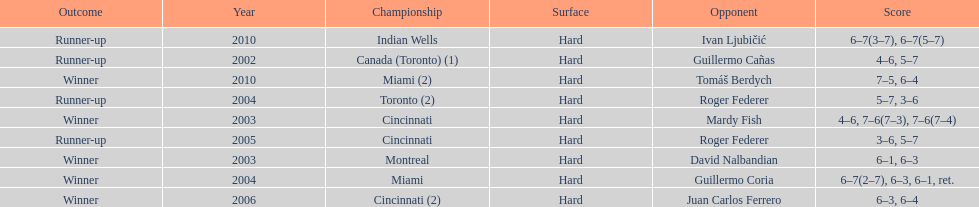How many times were roddick's opponents not from the usa? 8. Can you parse all the data within this table? {'header': ['Outcome', 'Year', 'Championship', 'Surface', 'Opponent', 'Score'], 'rows': [['Runner-up', '2010', 'Indian Wells', 'Hard', 'Ivan Ljubičić', '6–7(3–7), 6–7(5–7)'], ['Runner-up', '2002', 'Canada (Toronto) (1)', 'Hard', 'Guillermo Cañas', '4–6, 5–7'], ['Winner', '2010', 'Miami (2)', 'Hard', 'Tomáš Berdych', '7–5, 6–4'], ['Runner-up', '2004', 'Toronto (2)', 'Hard', 'Roger Federer', '5–7, 3–6'], ['Winner', '2003', 'Cincinnati', 'Hard', 'Mardy Fish', '4–6, 7–6(7–3), 7–6(7–4)'], ['Runner-up', '2005', 'Cincinnati', 'Hard', 'Roger Federer', '3–6, 5–7'], ['Winner', '2003', 'Montreal', 'Hard', 'David Nalbandian', '6–1, 6–3'], ['Winner', '2004', 'Miami', 'Hard', 'Guillermo Coria', '6–7(2–7), 6–3, 6–1, ret.'], ['Winner', '2006', 'Cincinnati (2)', 'Hard', 'Juan Carlos Ferrero', '6–3, 6–4']]} 